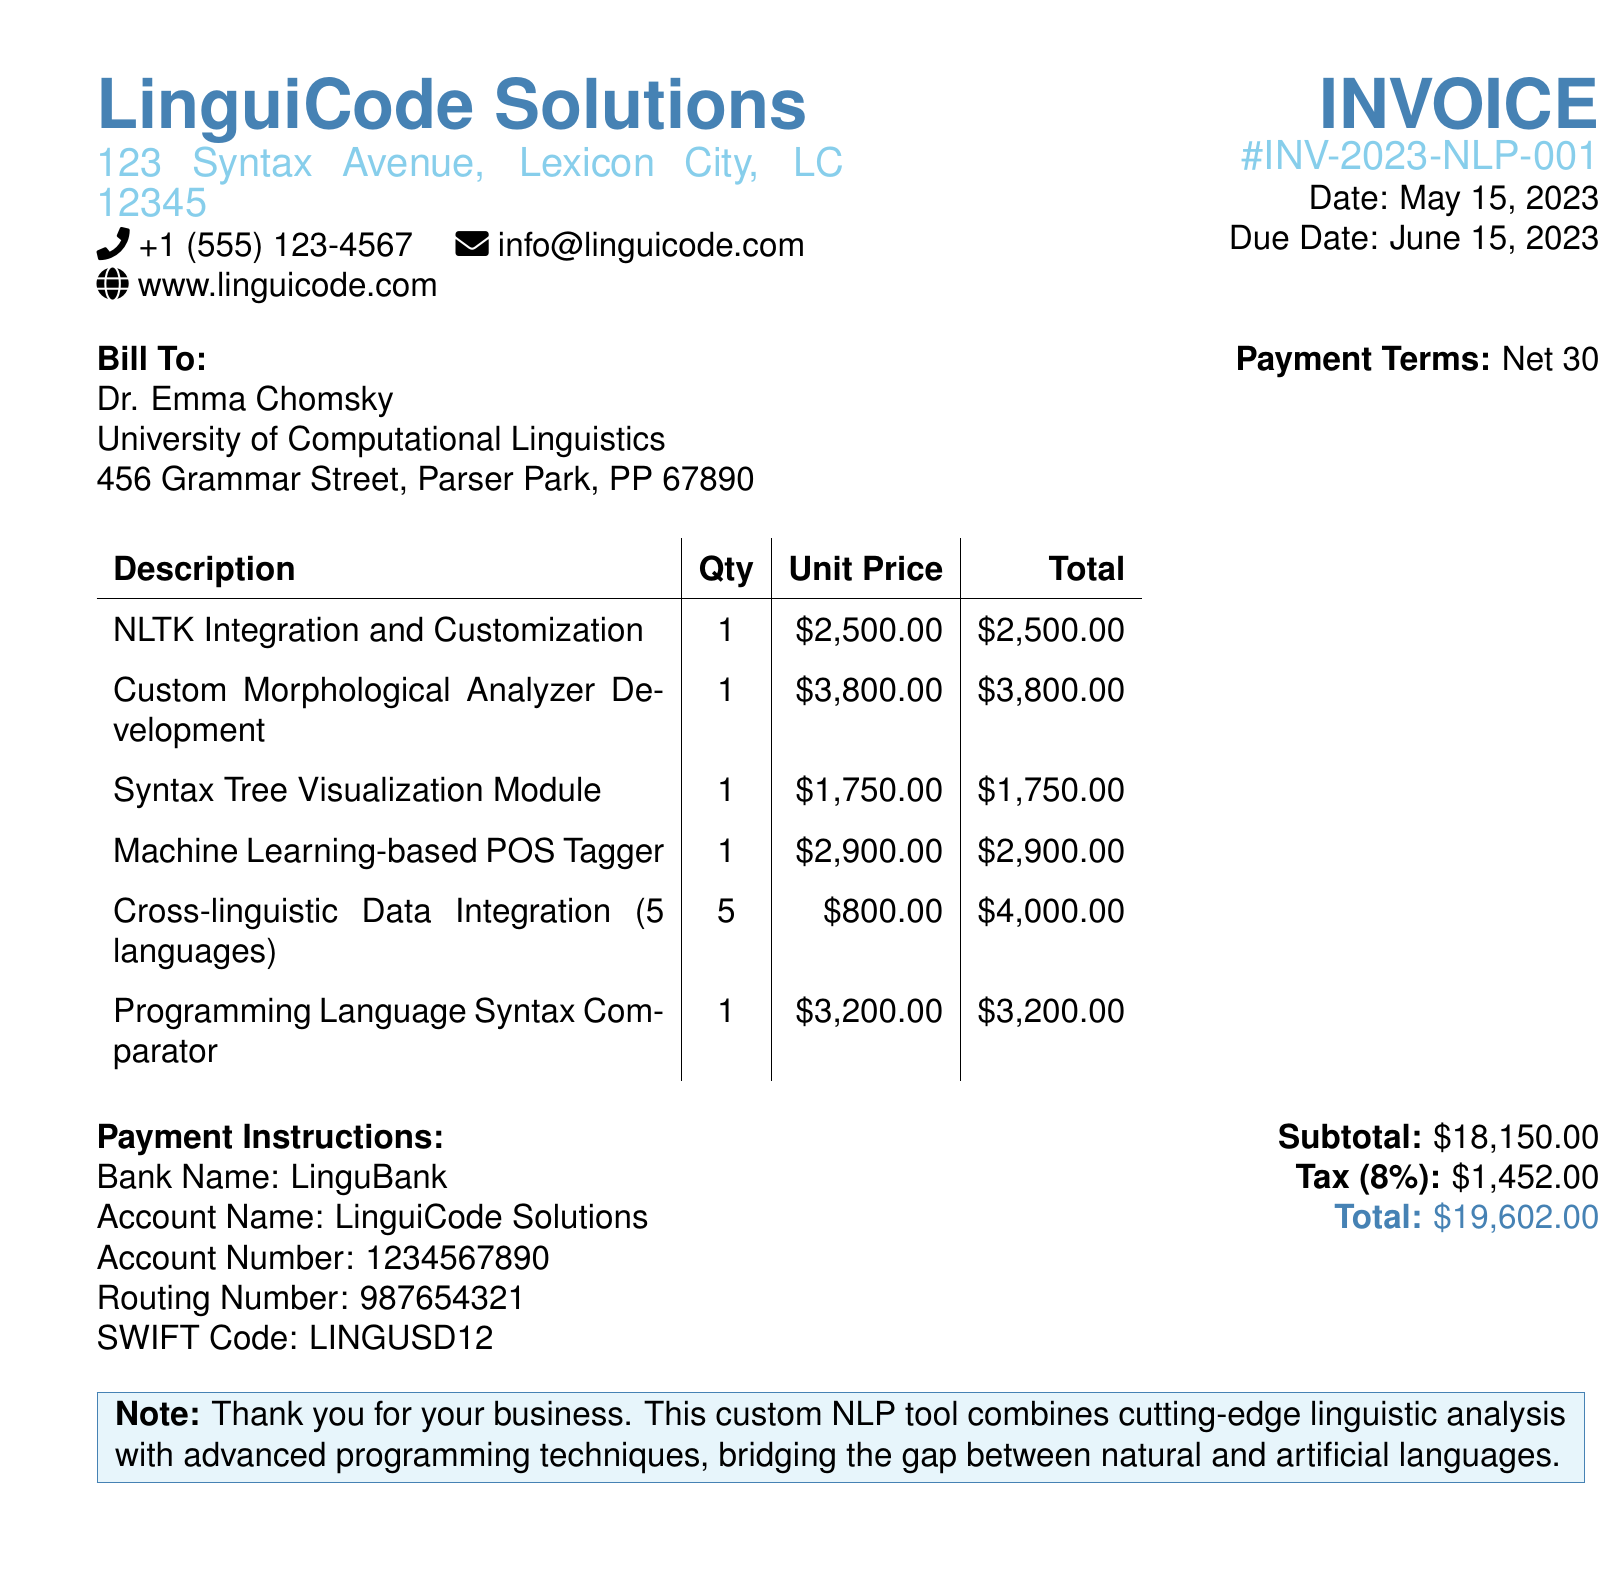What is the invoice number? The invoice number is listed in the document header, which identifies this specific transaction.
Answer: INV-2023-NLP-001 Who is the bill to? The bill is addressed to the person or organization receiving the invoice, here specified as Dr. Emma Chomsky.
Answer: Dr. Emma Chomsky What is the total amount due? The total amount due is calculated at the bottom of the invoice after adding up the subtotal and tax.
Answer: $19,602.00 How many languages are involved in the Cross-linguistic Data Integration? This specific item details the number of languages integrated into the project, which is mentioned in its description.
Answer: 5 languages What is the due date for payment? The due date is noted in the invoice header, indicating when the payment should be made.
Answer: June 15, 2023 What is the tax percentage applied? The document specifies the tax applied to the invoice subtotal, which is noted in the financial section.
Answer: 8% What is the subtotal before tax? The subtotal is presented in the final calculations of the document before the tax is added.
Answer: $18,150.00 Which module is related to syntax tree visualization? Specific modules are listed in the invoice, revealing the details of the services provided, including the syntax tree visualization.
Answer: Syntax Tree Visualization Module 